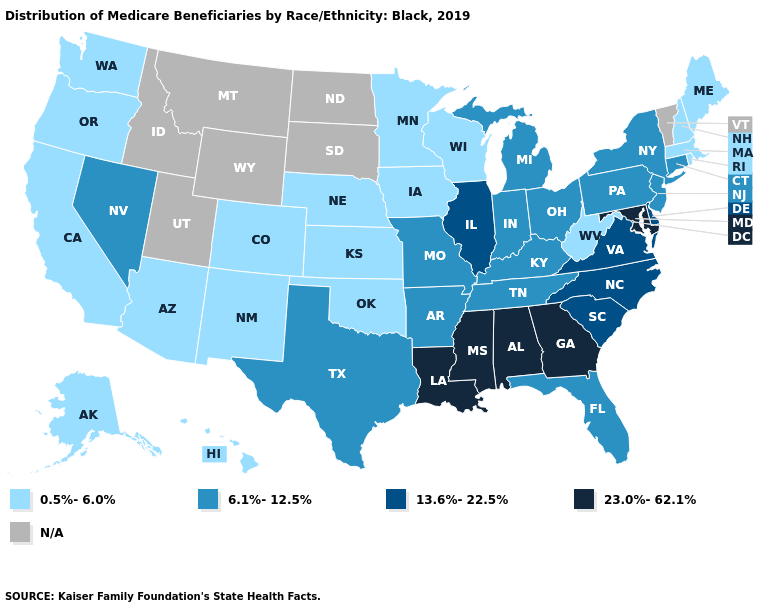Which states have the lowest value in the USA?
Short answer required. Alaska, Arizona, California, Colorado, Hawaii, Iowa, Kansas, Maine, Massachusetts, Minnesota, Nebraska, New Hampshire, New Mexico, Oklahoma, Oregon, Rhode Island, Washington, West Virginia, Wisconsin. Which states have the lowest value in the West?
Be succinct. Alaska, Arizona, California, Colorado, Hawaii, New Mexico, Oregon, Washington. Among the states that border North Carolina , does Tennessee have the lowest value?
Answer briefly. Yes. What is the lowest value in the USA?
Quick response, please. 0.5%-6.0%. Among the states that border Iowa , which have the lowest value?
Concise answer only. Minnesota, Nebraska, Wisconsin. Does the first symbol in the legend represent the smallest category?
Keep it brief. Yes. What is the highest value in the USA?
Concise answer only. 23.0%-62.1%. What is the value of Maryland?
Answer briefly. 23.0%-62.1%. Name the states that have a value in the range 6.1%-12.5%?
Short answer required. Arkansas, Connecticut, Florida, Indiana, Kentucky, Michigan, Missouri, Nevada, New Jersey, New York, Ohio, Pennsylvania, Tennessee, Texas. Is the legend a continuous bar?
Quick response, please. No. Name the states that have a value in the range 6.1%-12.5%?
Answer briefly. Arkansas, Connecticut, Florida, Indiana, Kentucky, Michigan, Missouri, Nevada, New Jersey, New York, Ohio, Pennsylvania, Tennessee, Texas. 